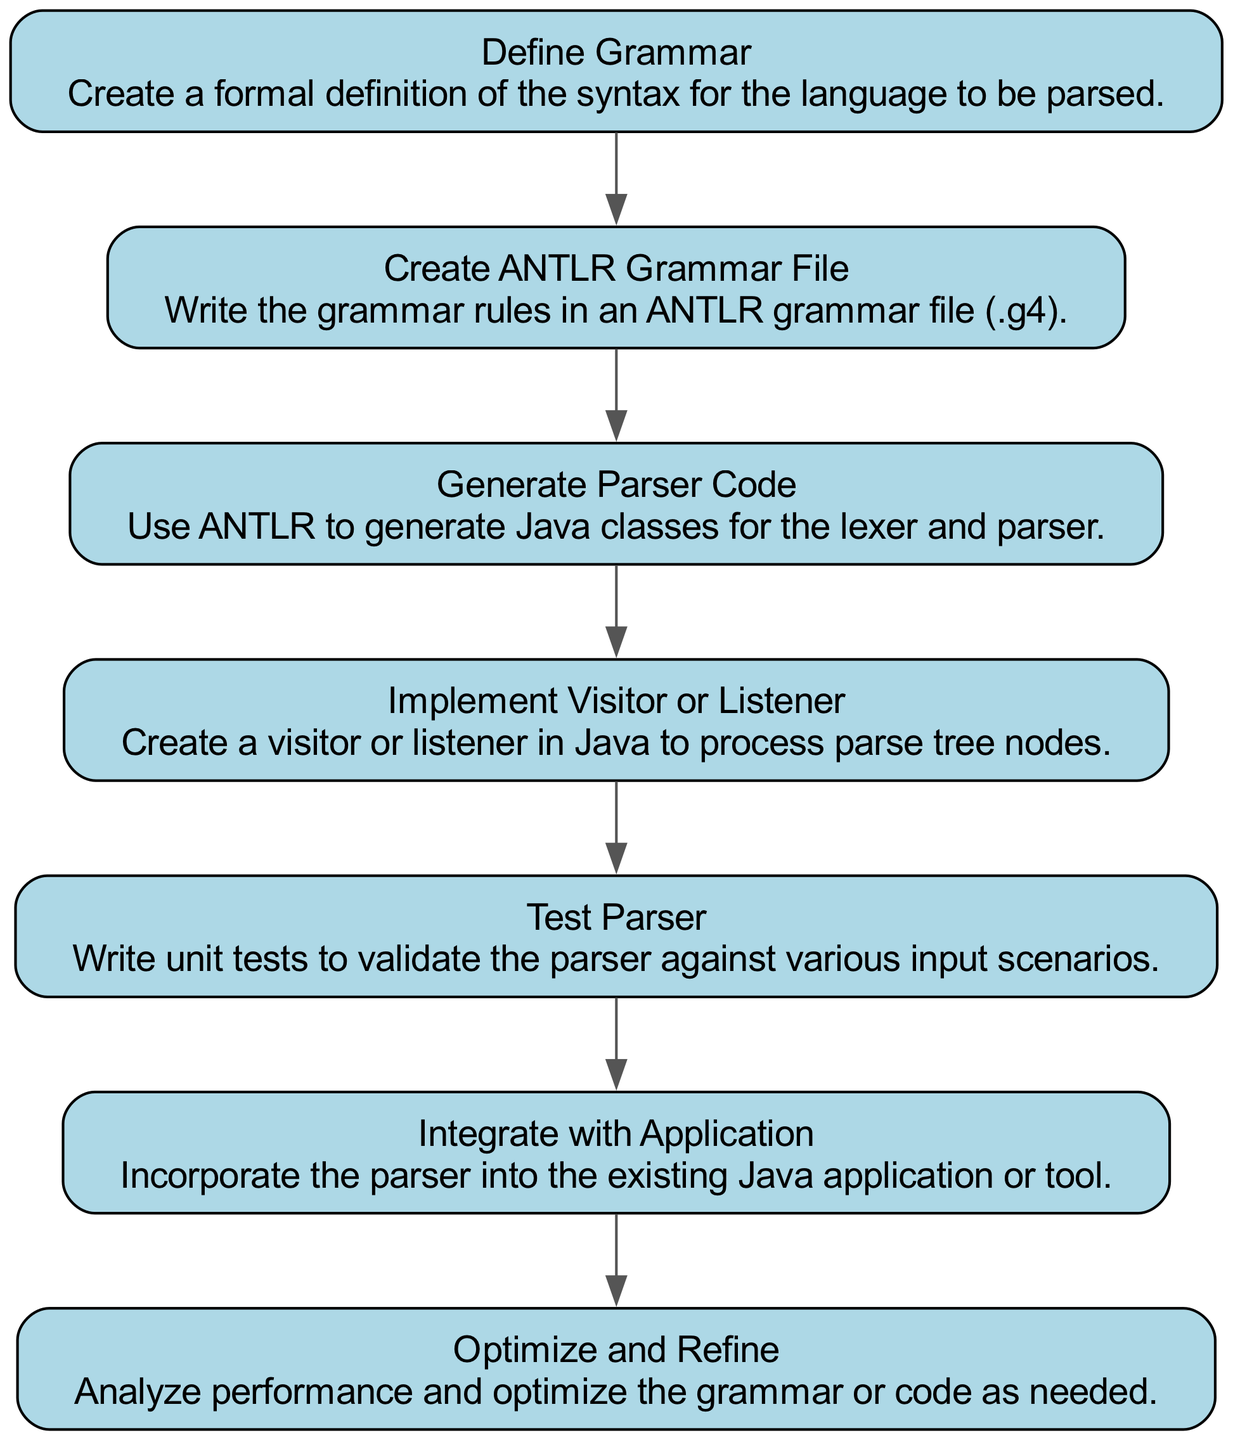What is the first step in the workflow? The first step is "Define Grammar," which is the starting point of the flow chart for developing a new parser using ANTLR.
Answer: Define Grammar How many nodes are in the diagram? The diagram has seven nodes, each representing a step in the parser development workflow.
Answer: 7 What follows "Create ANTLR Grammar File"? "Generate Parser Code" is the next step that follows "Create ANTLR Grammar File."
Answer: Generate Parser Code What is the last step in the workflow? The last step is "Optimize and Refine," indicating it comes after all other steps have been completed.
Answer: Optimize and Refine Which step involves writing unit tests? The step that involves writing unit tests is "Test Parser," which comes after implementing the visitor or listener.
Answer: Test Parser How does "Integrate with Application" relate to previous steps? "Integrate with Application" comes after "Test Parser," meaning that integration happens after the parser has been tested successfully.
Answer: Integrate with Application What step involves processing parse tree nodes? The step called "Implement Visitor or Listener" is where processing of parse tree nodes takes place.
Answer: Implement Visitor or Listener 